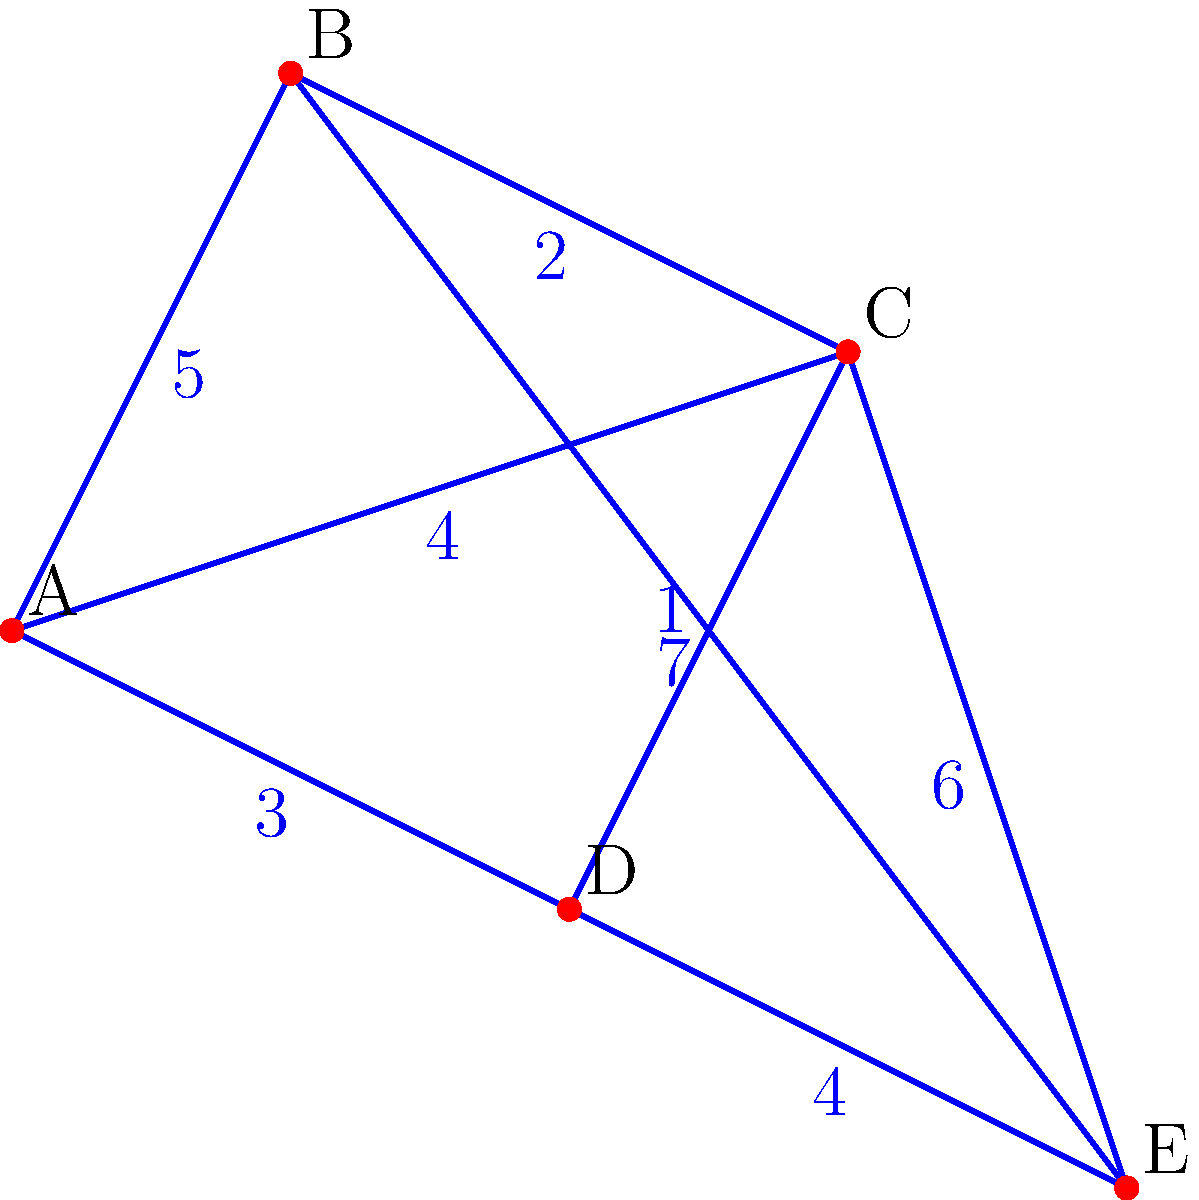As part of your initiative to improve community connectivity, you've been presented with a graph representing various community centers (nodes A, B, C, D, and E) and the distances between them. Your task is to determine the minimum total distance required to connect all community centers while ensuring every center is accessible. What is the sum of the distances in the minimum spanning tree for this network of community centers? To find the minimum spanning tree (MST) of this graph, we'll use Kruskal's algorithm, which is an efficient method for finding the MST in a weighted, undirected graph. Here's the step-by-step process:

1. Sort all edges by weight in ascending order:
   C-D (1), B-C (2), A-D (3), A-C (4), D-E (4), A-B (5), C-E (6), B-E (7)

2. Start with an empty MST and add edges in order, skipping those that would create a cycle:
   - Add C-D (1)
   - Add B-C (2)
   - Add A-D (3)
   - Skip A-C (4) as it would create a cycle
   - Add D-E (4)

3. At this point, we have connected all vertices (community centers) with 4 edges, which is the minimum required for a tree with 5 vertices.

4. The MST consists of the edges:
   C-D (1), B-C (2), A-D (3), D-E (4)

5. Sum up the weights of these edges:
   1 + 2 + 3 + 4 = 10

Therefore, the minimum total distance required to connect all community centers is 10 units.
Answer: 10 units 